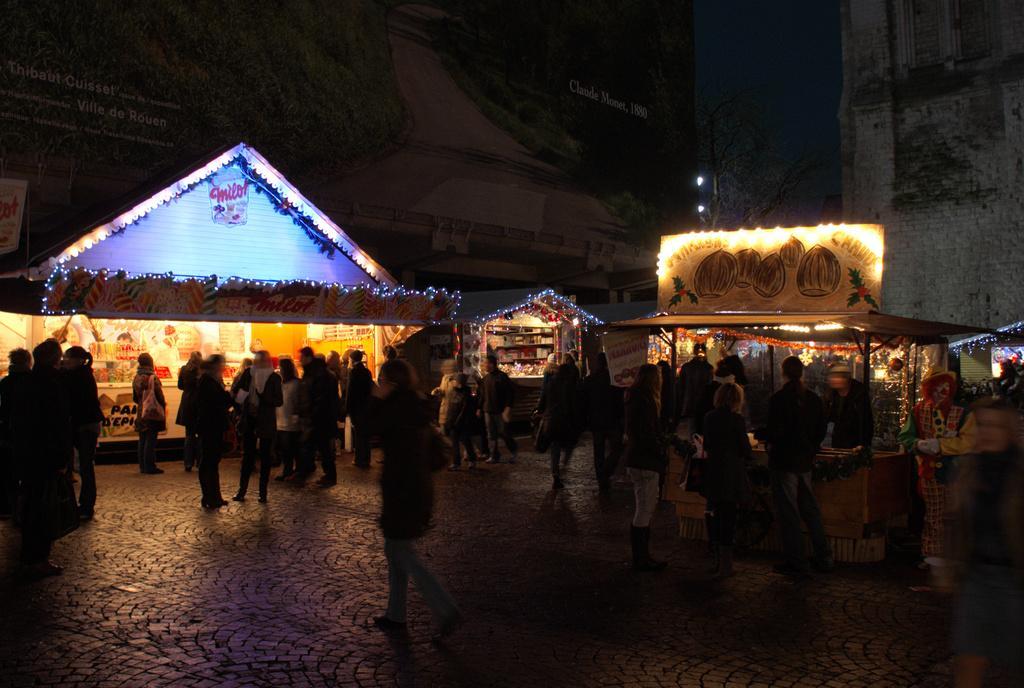In one or two sentences, can you explain what this image depicts? In this image I see number of people and I see number of shops and I see the lights. In the background I see the trees over here and I see the lights over here too and it is a bit dark and I see the ground. 